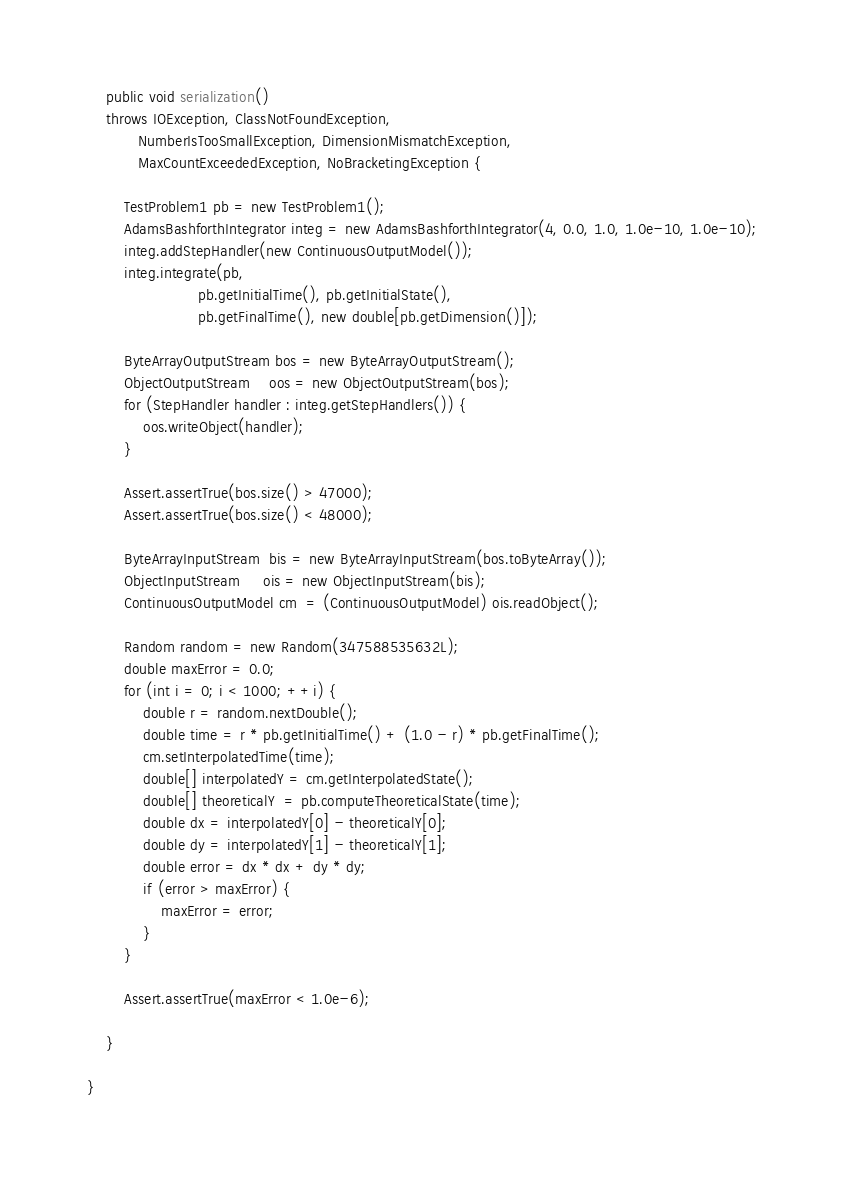<code> <loc_0><loc_0><loc_500><loc_500><_Java_>    public void serialization()
    throws IOException, ClassNotFoundException,
           NumberIsTooSmallException, DimensionMismatchException,
           MaxCountExceededException, NoBracketingException {

        TestProblem1 pb = new TestProblem1();
        AdamsBashforthIntegrator integ = new AdamsBashforthIntegrator(4, 0.0, 1.0, 1.0e-10, 1.0e-10);
        integ.addStepHandler(new ContinuousOutputModel());
        integ.integrate(pb,
                        pb.getInitialTime(), pb.getInitialState(),
                        pb.getFinalTime(), new double[pb.getDimension()]);

        ByteArrayOutputStream bos = new ByteArrayOutputStream();
        ObjectOutputStream    oos = new ObjectOutputStream(bos);
        for (StepHandler handler : integ.getStepHandlers()) {
            oos.writeObject(handler);
        }

        Assert.assertTrue(bos.size() > 47000);
        Assert.assertTrue(bos.size() < 48000);

        ByteArrayInputStream  bis = new ByteArrayInputStream(bos.toByteArray());
        ObjectInputStream     ois = new ObjectInputStream(bis);
        ContinuousOutputModel cm  = (ContinuousOutputModel) ois.readObject();

        Random random = new Random(347588535632L);
        double maxError = 0.0;
        for (int i = 0; i < 1000; ++i) {
            double r = random.nextDouble();
            double time = r * pb.getInitialTime() + (1.0 - r) * pb.getFinalTime();
            cm.setInterpolatedTime(time);
            double[] interpolatedY = cm.getInterpolatedState();
            double[] theoreticalY  = pb.computeTheoreticalState(time);
            double dx = interpolatedY[0] - theoreticalY[0];
            double dy = interpolatedY[1] - theoreticalY[1];
            double error = dx * dx + dy * dy;
            if (error > maxError) {
                maxError = error;
            }
        }

        Assert.assertTrue(maxError < 1.0e-6);

    }

}
</code> 